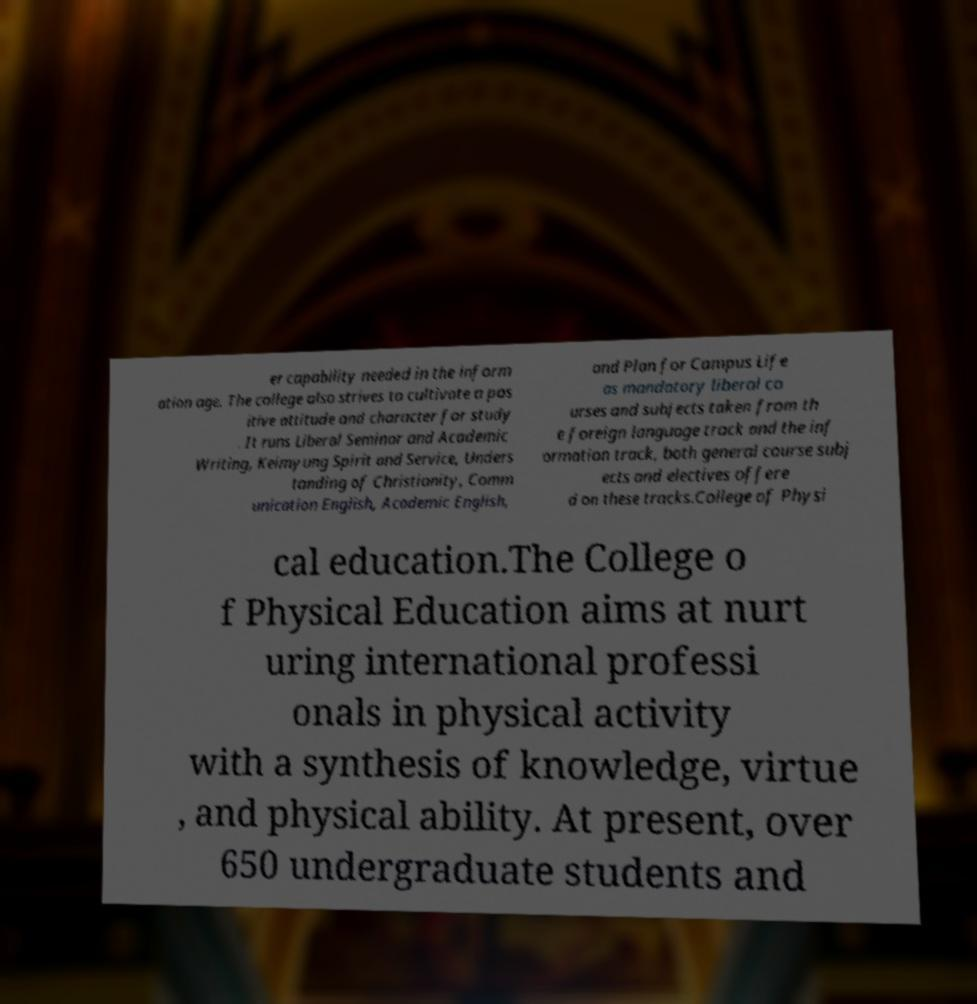Can you read and provide the text displayed in the image?This photo seems to have some interesting text. Can you extract and type it out for me? er capability needed in the inform ation age. The college also strives to cultivate a pos itive attitude and character for study . It runs Liberal Seminar and Academic Writing, Keimyung Spirit and Service, Unders tanding of Christianity, Comm unication English, Academic English, and Plan for Campus Life as mandatory liberal co urses and subjects taken from th e foreign language track and the inf ormation track, both general course subj ects and electives offere d on these tracks.College of Physi cal education.The College o f Physical Education aims at nurt uring international professi onals in physical activity with a synthesis of knowledge, virtue , and physical ability. At present, over 650 undergraduate students and 